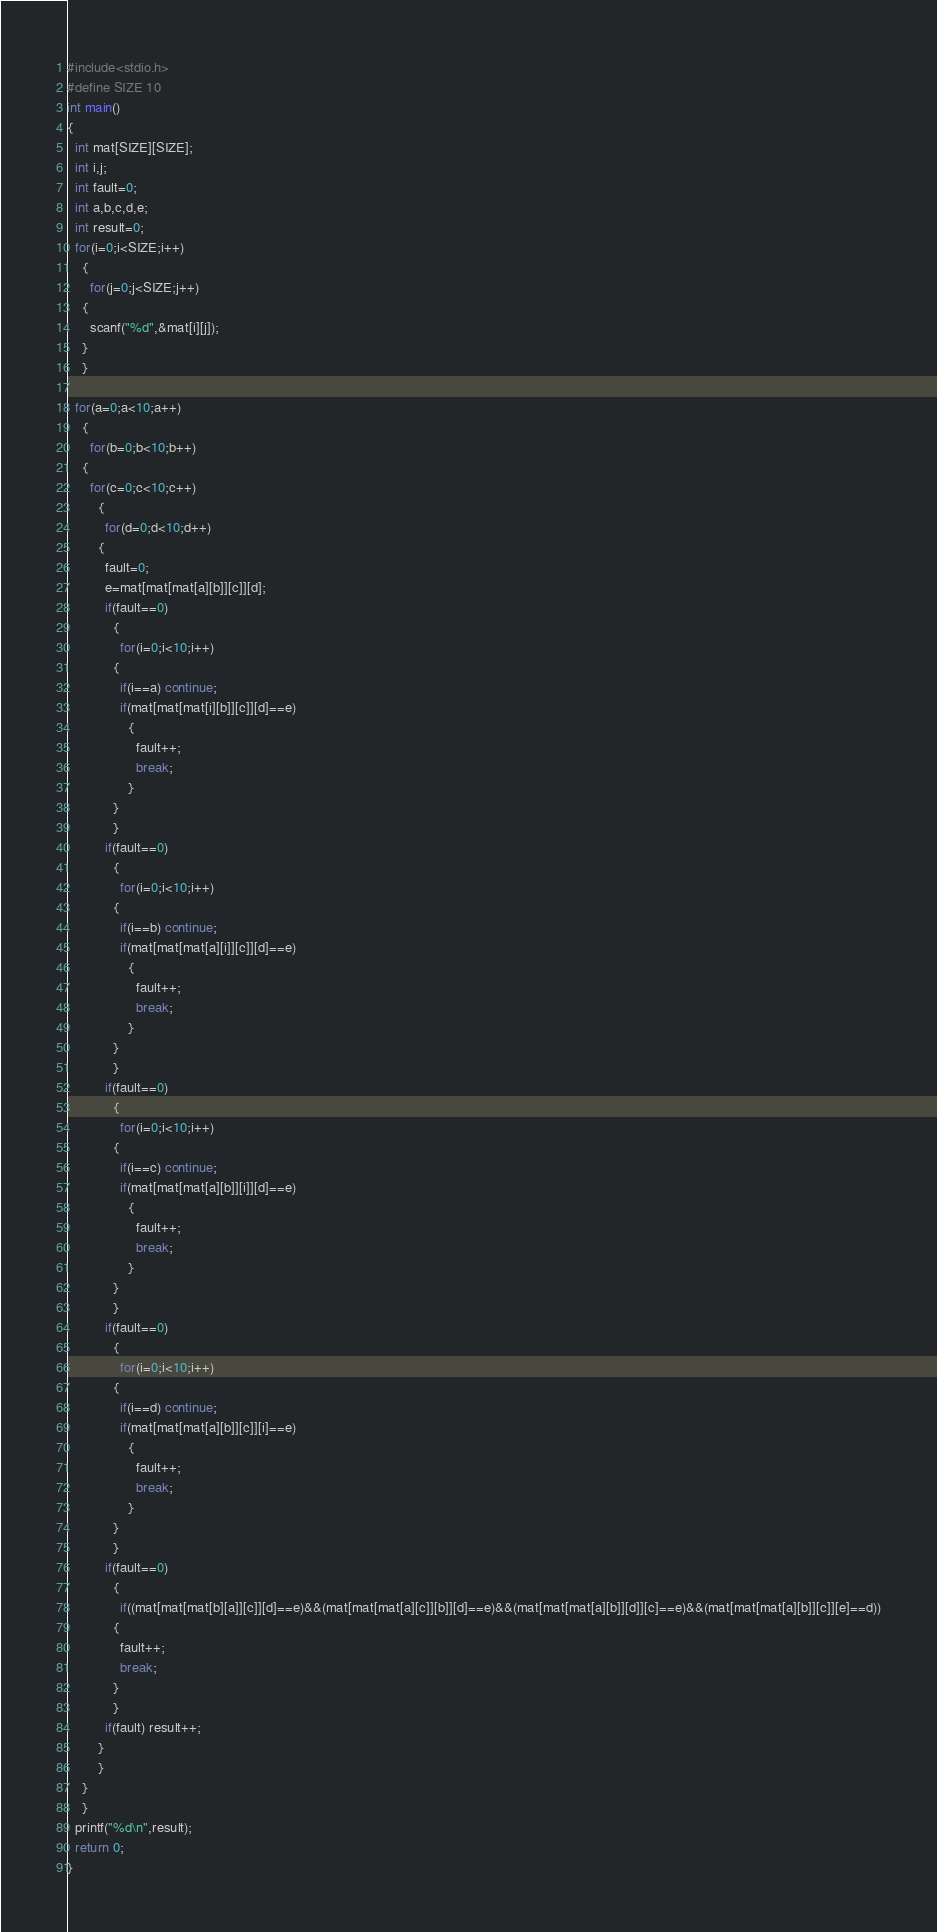<code> <loc_0><loc_0><loc_500><loc_500><_C++_>#include<stdio.h>
#define SIZE 10
int main()
{
  int mat[SIZE][SIZE];
  int i,j;
  int fault=0;
  int a,b,c,d,e;
  int result=0;
  for(i=0;i<SIZE;i++)
    {
      for(j=0;j<SIZE;j++)
	{
	  scanf("%d",&mat[i][j]);
	}
    }

  for(a=0;a<10;a++)
    {
      for(b=0;b<10;b++)
	{
	  for(c=0;c<10;c++)
	    {
	      for(d=0;d<10;d++)
		{
		  fault=0;
		  e=mat[mat[mat[a][b]][c]][d];
		  if(fault==0)
		    {
		      for(i=0;i<10;i++)
			{
			  if(i==a) continue;
			  if(mat[mat[mat[i][b]][c]][d]==e)
			    {
			      fault++;
			      break;
			    }
			}
		    }
		  if(fault==0)
		    {
		      for(i=0;i<10;i++)
			{
			  if(i==b) continue;
			  if(mat[mat[mat[a][i]][c]][d]==e)
			    {
			      fault++;
			      break;
			    }
			}
		    }		  
		  if(fault==0)
		    {
		      for(i=0;i<10;i++)
			{
			  if(i==c) continue;
			  if(mat[mat[mat[a][b]][i]][d]==e)
			    {
			      fault++;
			      break;
			    }
			}
		    }
		  if(fault==0)
		    {
		      for(i=0;i<10;i++)
			{
			  if(i==d) continue;
			  if(mat[mat[mat[a][b]][c]][i]==e)
			    {
			      fault++;
			      break;
			    }
			}
		    }
		  if(fault==0)
		    {
		      if((mat[mat[mat[b][a]][c]][d]==e)&&(mat[mat[mat[a][c]][b]][d]==e)&&(mat[mat[mat[a][b]][d]][c]==e)&&(mat[mat[mat[a][b]][c]][e]==d))
			{
			  fault++;
			  break;
			}
		    }
		  if(fault) result++;		  
		}
	    }
	}
    }
  printf("%d\n",result);
  return 0;
}</code> 